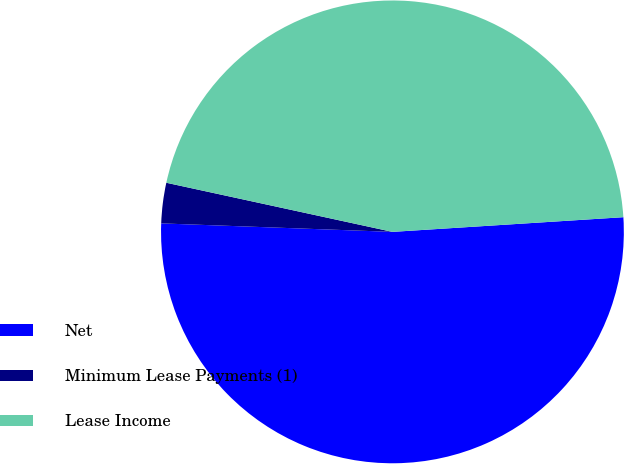Convert chart to OTSL. <chart><loc_0><loc_0><loc_500><loc_500><pie_chart><fcel>Net<fcel>Minimum Lease Payments (1)<fcel>Lease Income<nl><fcel>51.59%<fcel>2.82%<fcel>45.58%<nl></chart> 